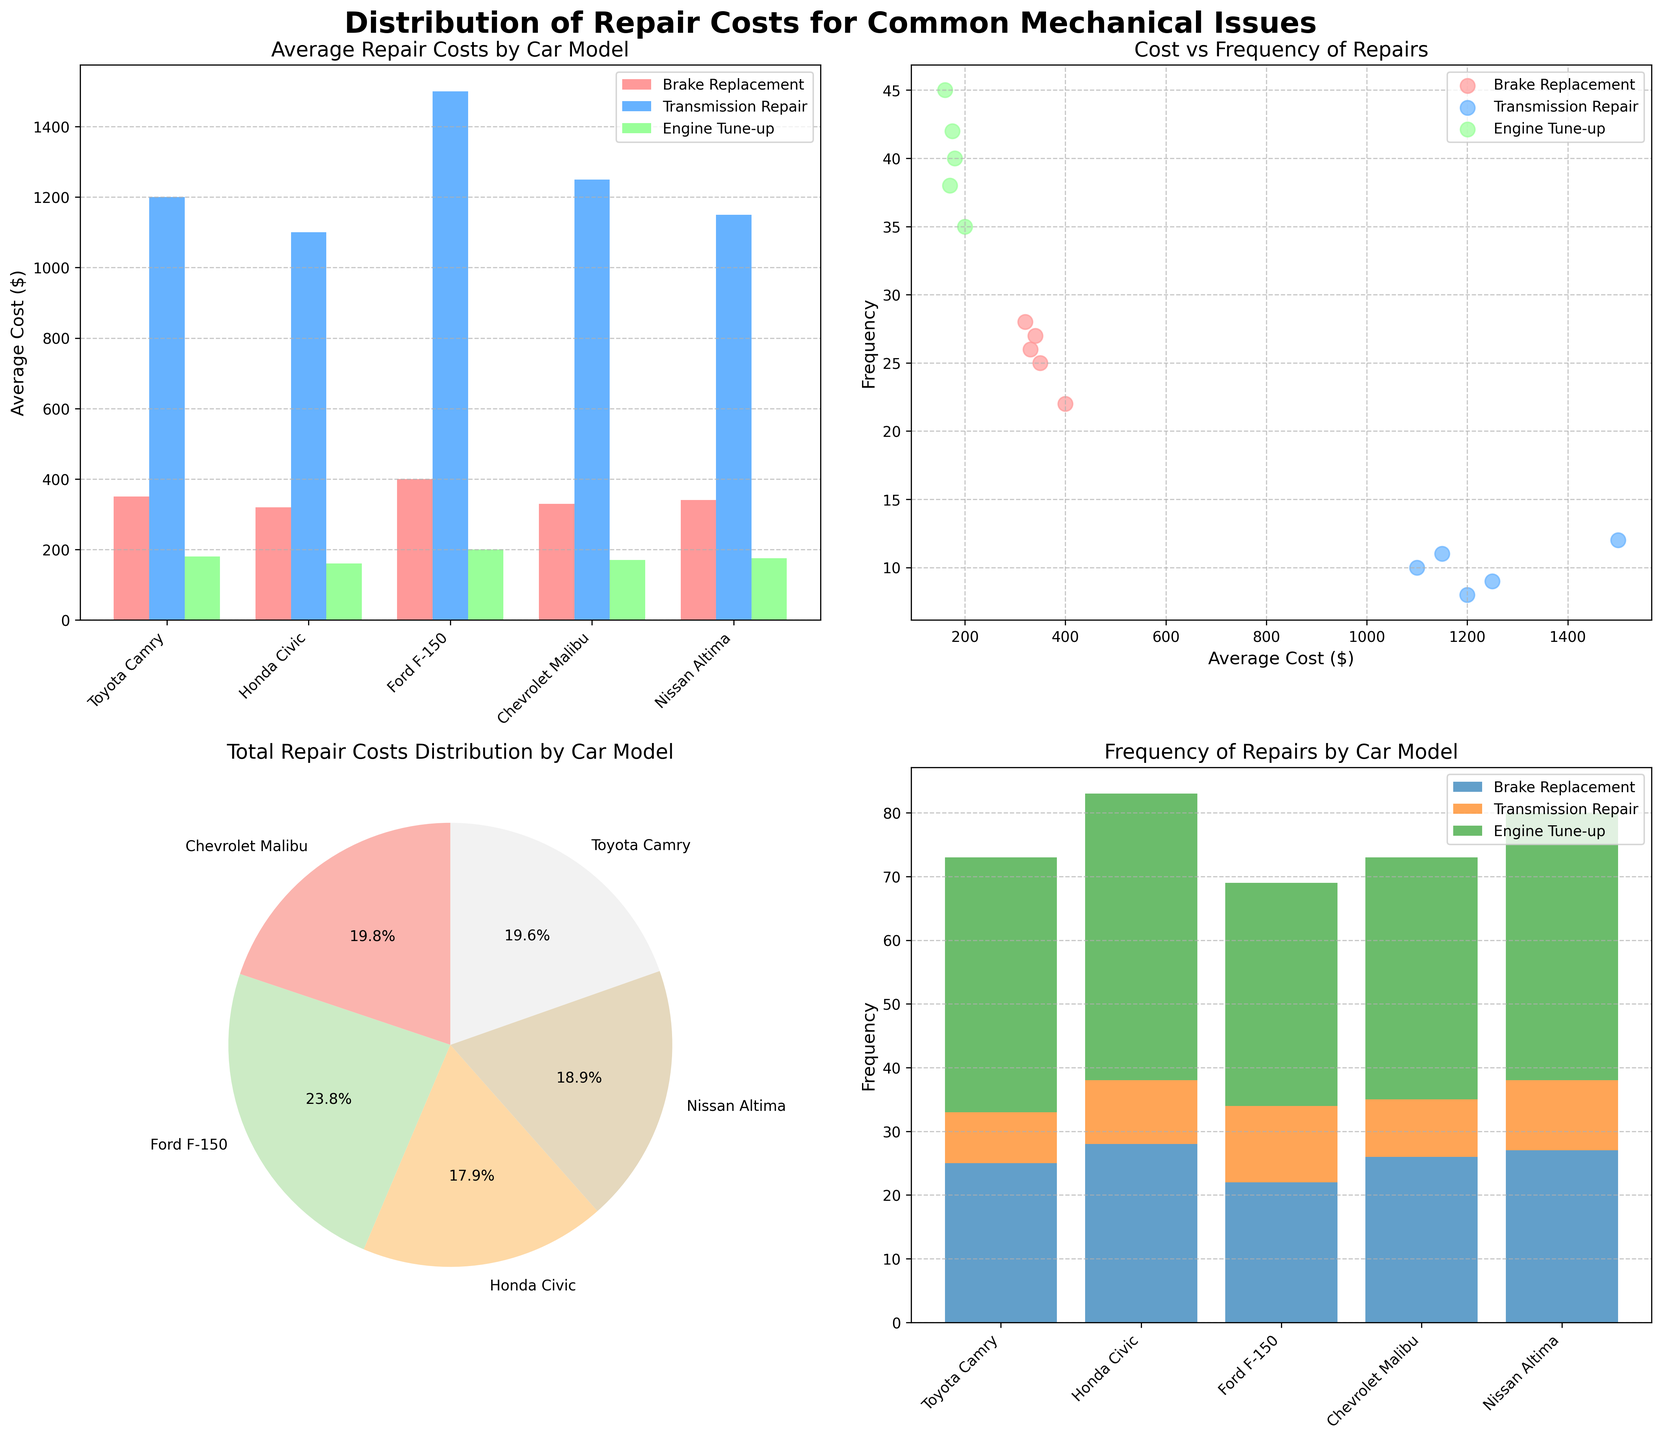Which car model has the highest average cost for brake replacement? Check the bar plot in subplot ax1. The "Ford F-150" shows the tallest bar for brake replacement.
Answer: Ford F-150 Which repair type has the highest frequency for the Honda Civic? Look at the stacked bar chart on subplot ax4. The "Engine Tune-up" section is the tallest for the Honda Civic.
Answer: Engine Tune-up How does the total repair cost distribution vary across car models? Refer to the pie chart in subplot ax3. Each slice represents the total cost distribution; visually compare the slice sizes.
Answer: Varies by model, with Nissan Altima having the largest slice Which repair type for which car model has the lowest average cost? In the scatter plot on subplot ax2, the lowest point along the x-axis (average cost) for any model and repair type is identified. "Honda Civic" has a low "Engine Tune-up" cost of $160.
Answer: Honda Civic, Engine Tune-up What is the relationship between transmission repair costs and frequency across all models? On the scatter plot in subplot ax2, observe the "Transmission Repair" points (in blue). Higher average costs tend to have lower frequencies.
Answer: Higher costs generally have lower frequencies Which car model has the highest total average cost for all repair types combined? Sum the average costs of all repair types for each car model from subplot ax1. "Ford F-150" has the highest combined cost when summed (400 + 1500 + 200).
Answer: Ford F-150 What proportion of the total repair costs does the Toyota Camry represent? See the pie chart in subplot ax3. The Toyota Camry’s slice in percentage terms represents its proportion of total costs.
Answer: 20.8% How do the costs vs. frequencies compare between brake replacements and engine tune-ups? Refer to subplot ax2. Compare the positions of red dots (Brake Replacement) and green dots (Engine Tune-up). Red dots usually have higher costs but lower frequencies compared to green dots.
Answer: Brake Replacement: higher costs, lower frequencies; Engine Tune-up: lower costs, higher frequencies 